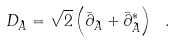<formula> <loc_0><loc_0><loc_500><loc_500>D _ { \hat { A } } = \sqrt { 2 } \left ( \bar { \partial } _ { \hat { A } } + \bar { \partial } _ { \hat { A } } ^ { * } \right ) \ .</formula> 